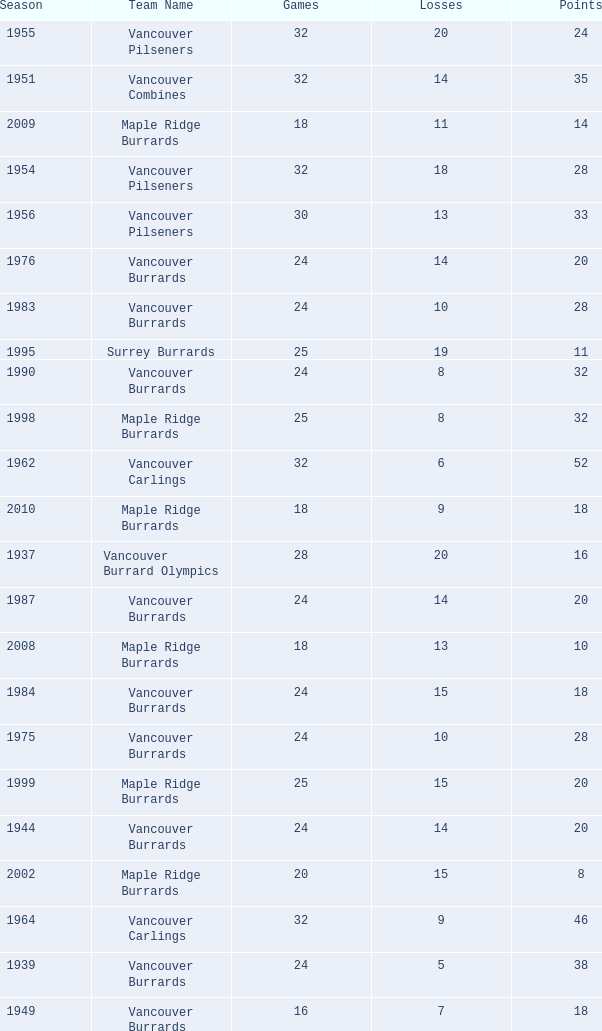What's the total number of points when the vancouver burrards have fewer than 9 losses and more than 24 games? 1.0. 